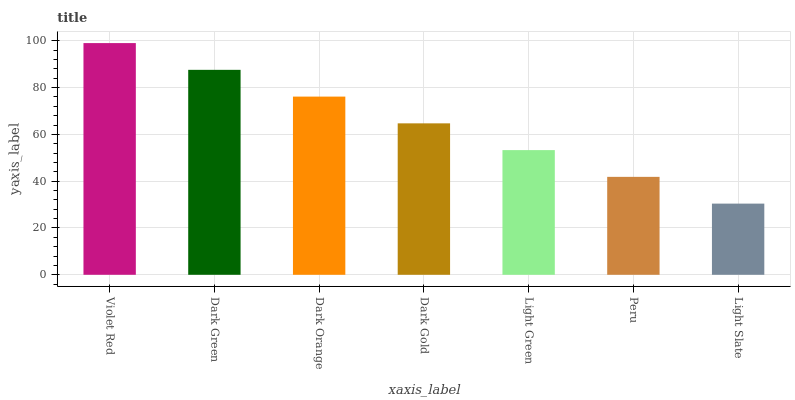Is Light Slate the minimum?
Answer yes or no. Yes. Is Violet Red the maximum?
Answer yes or no. Yes. Is Dark Green the minimum?
Answer yes or no. No. Is Dark Green the maximum?
Answer yes or no. No. Is Violet Red greater than Dark Green?
Answer yes or no. Yes. Is Dark Green less than Violet Red?
Answer yes or no. Yes. Is Dark Green greater than Violet Red?
Answer yes or no. No. Is Violet Red less than Dark Green?
Answer yes or no. No. Is Dark Gold the high median?
Answer yes or no. Yes. Is Dark Gold the low median?
Answer yes or no. Yes. Is Light Slate the high median?
Answer yes or no. No. Is Dark Green the low median?
Answer yes or no. No. 